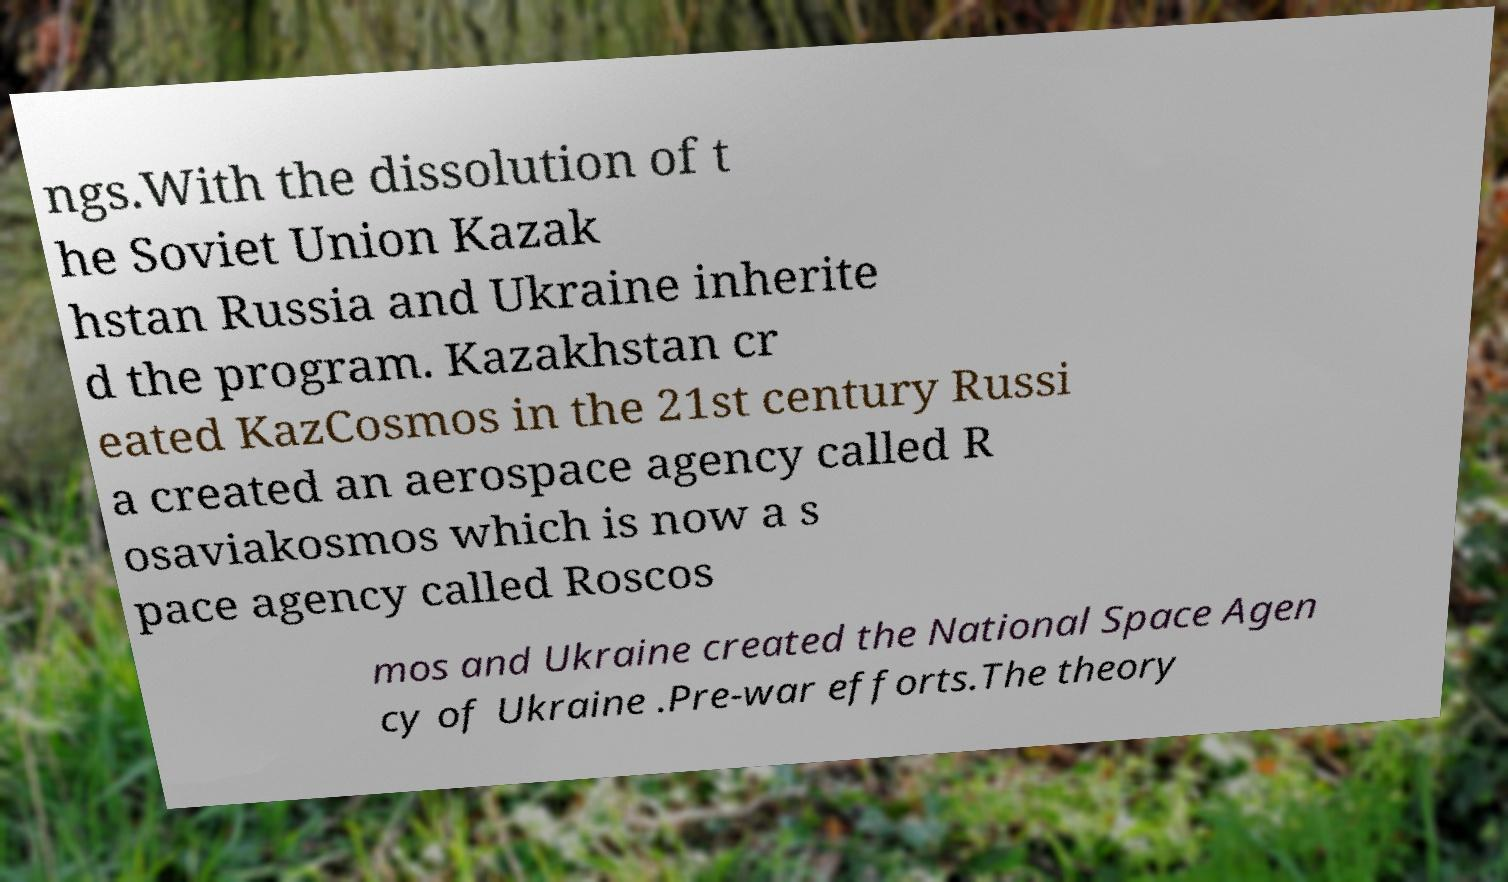What messages or text are displayed in this image? I need them in a readable, typed format. ngs.With the dissolution of t he Soviet Union Kazak hstan Russia and Ukraine inherite d the program. Kazakhstan cr eated KazCosmos in the 21st century Russi a created an aerospace agency called R osaviakosmos which is now a s pace agency called Roscos mos and Ukraine created the National Space Agen cy of Ukraine .Pre-war efforts.The theory 